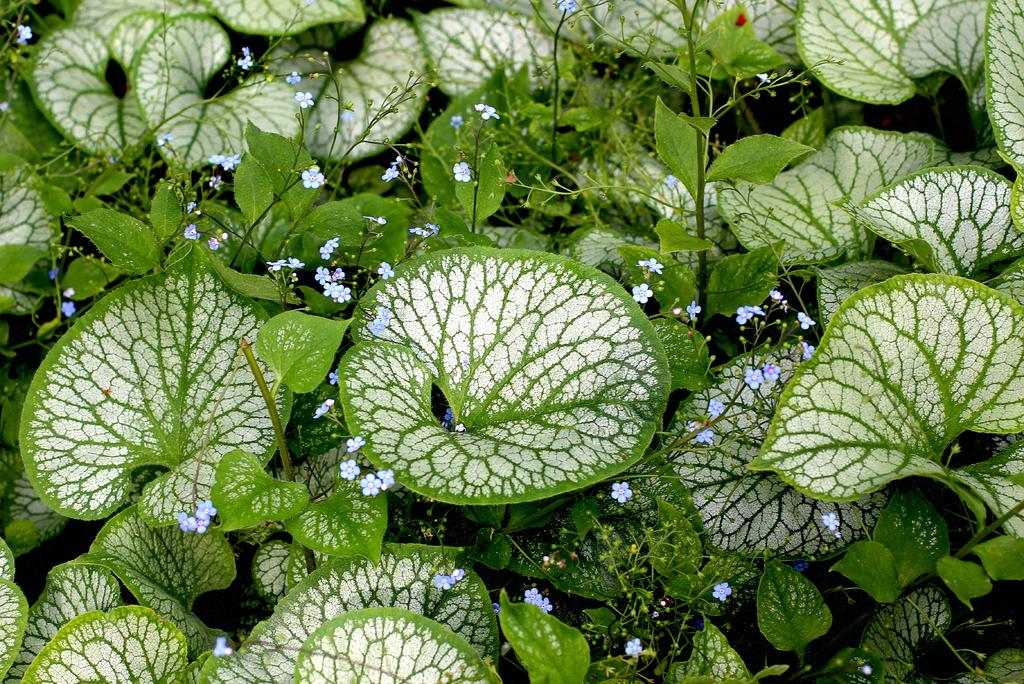What type of living organisms are present in the image? There are plants in the image. What color are the flowers of the plants in the image? The flowers of the plants in the image are blue in color. What color are the leaves of the plants in the image? The leaves of the plants in the image are green in color. What is the color combination of some of the leaves in the image? Some of the leaves in the image have a white and green color combination. What can be observed about the background of the image? The background of the image is dark in color. What force is being applied to the plants in the image? There is no force being applied to the plants in the image; they are stationary. Who is the owner of the plants in the image? There is no information about the owner of the plants in the image. 